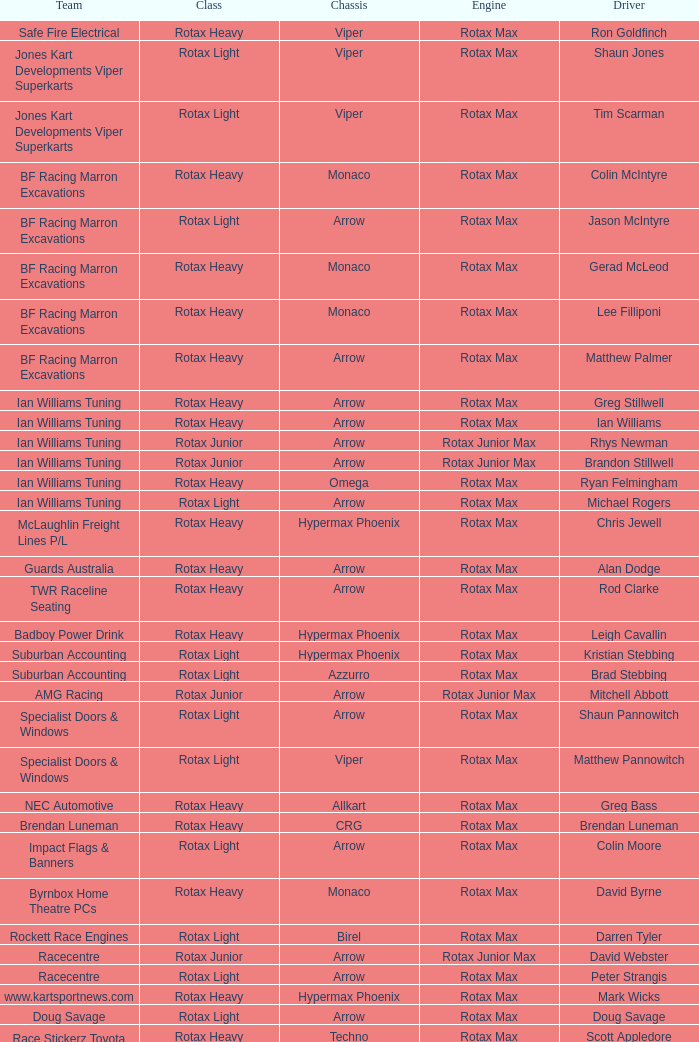What is the name of the team that belongs to the rotax light class? Jones Kart Developments Viper Superkarts, Jones Kart Developments Viper Superkarts, BF Racing Marron Excavations, Ian Williams Tuning, Suburban Accounting, Suburban Accounting, Specialist Doors & Windows, Specialist Doors & Windows, Impact Flags & Banners, Rockett Race Engines, Racecentre, Doug Savage. 